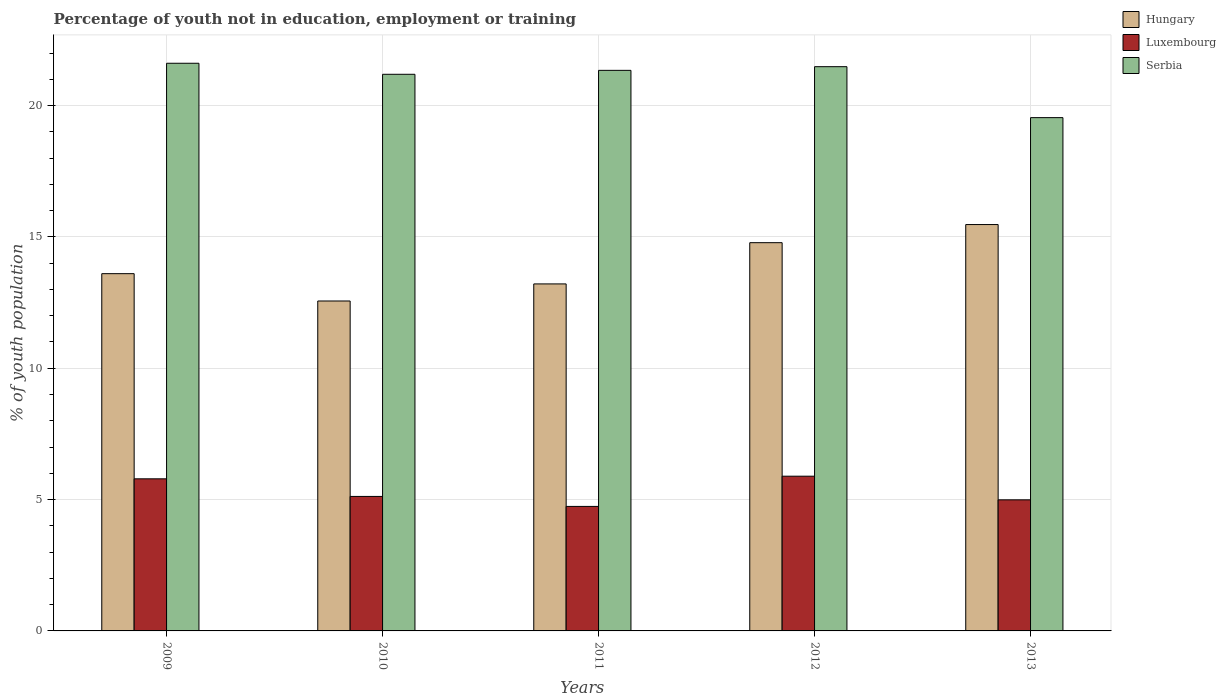How many groups of bars are there?
Offer a terse response. 5. Are the number of bars per tick equal to the number of legend labels?
Provide a succinct answer. Yes. Are the number of bars on each tick of the X-axis equal?
Offer a very short reply. Yes. How many bars are there on the 2nd tick from the left?
Keep it short and to the point. 3. What is the percentage of unemployed youth population in in Serbia in 2013?
Your answer should be very brief. 19.54. Across all years, what is the maximum percentage of unemployed youth population in in Hungary?
Your response must be concise. 15.47. Across all years, what is the minimum percentage of unemployed youth population in in Hungary?
Offer a terse response. 12.56. In which year was the percentage of unemployed youth population in in Serbia maximum?
Your answer should be very brief. 2009. In which year was the percentage of unemployed youth population in in Hungary minimum?
Offer a terse response. 2010. What is the total percentage of unemployed youth population in in Hungary in the graph?
Your answer should be very brief. 69.62. What is the difference between the percentage of unemployed youth population in in Hungary in 2011 and that in 2013?
Keep it short and to the point. -2.26. What is the difference between the percentage of unemployed youth population in in Serbia in 2009 and the percentage of unemployed youth population in in Luxembourg in 2013?
Offer a very short reply. 16.62. What is the average percentage of unemployed youth population in in Hungary per year?
Your answer should be very brief. 13.92. In the year 2010, what is the difference between the percentage of unemployed youth population in in Luxembourg and percentage of unemployed youth population in in Hungary?
Make the answer very short. -7.44. What is the ratio of the percentage of unemployed youth population in in Serbia in 2011 to that in 2012?
Your answer should be very brief. 0.99. Is the difference between the percentage of unemployed youth population in in Luxembourg in 2009 and 2012 greater than the difference between the percentage of unemployed youth population in in Hungary in 2009 and 2012?
Ensure brevity in your answer.  Yes. What is the difference between the highest and the second highest percentage of unemployed youth population in in Hungary?
Offer a very short reply. 0.69. What is the difference between the highest and the lowest percentage of unemployed youth population in in Luxembourg?
Your answer should be very brief. 1.15. In how many years, is the percentage of unemployed youth population in in Serbia greater than the average percentage of unemployed youth population in in Serbia taken over all years?
Offer a terse response. 4. What does the 1st bar from the left in 2010 represents?
Provide a short and direct response. Hungary. What does the 3rd bar from the right in 2013 represents?
Offer a very short reply. Hungary. How many bars are there?
Your answer should be compact. 15. What is the difference between two consecutive major ticks on the Y-axis?
Provide a short and direct response. 5. Are the values on the major ticks of Y-axis written in scientific E-notation?
Your answer should be very brief. No. How many legend labels are there?
Your response must be concise. 3. How are the legend labels stacked?
Keep it short and to the point. Vertical. What is the title of the graph?
Provide a short and direct response. Percentage of youth not in education, employment or training. What is the label or title of the Y-axis?
Make the answer very short. % of youth population. What is the % of youth population of Hungary in 2009?
Your response must be concise. 13.6. What is the % of youth population in Luxembourg in 2009?
Give a very brief answer. 5.79. What is the % of youth population in Serbia in 2009?
Give a very brief answer. 21.61. What is the % of youth population of Hungary in 2010?
Give a very brief answer. 12.56. What is the % of youth population of Luxembourg in 2010?
Give a very brief answer. 5.12. What is the % of youth population of Serbia in 2010?
Your response must be concise. 21.19. What is the % of youth population in Hungary in 2011?
Give a very brief answer. 13.21. What is the % of youth population of Luxembourg in 2011?
Provide a short and direct response. 4.74. What is the % of youth population of Serbia in 2011?
Your response must be concise. 21.34. What is the % of youth population in Hungary in 2012?
Offer a very short reply. 14.78. What is the % of youth population in Luxembourg in 2012?
Your answer should be very brief. 5.89. What is the % of youth population in Serbia in 2012?
Your response must be concise. 21.48. What is the % of youth population in Hungary in 2013?
Keep it short and to the point. 15.47. What is the % of youth population of Luxembourg in 2013?
Provide a short and direct response. 4.99. What is the % of youth population in Serbia in 2013?
Make the answer very short. 19.54. Across all years, what is the maximum % of youth population in Hungary?
Keep it short and to the point. 15.47. Across all years, what is the maximum % of youth population of Luxembourg?
Your answer should be very brief. 5.89. Across all years, what is the maximum % of youth population of Serbia?
Your answer should be very brief. 21.61. Across all years, what is the minimum % of youth population in Hungary?
Offer a terse response. 12.56. Across all years, what is the minimum % of youth population in Luxembourg?
Provide a short and direct response. 4.74. Across all years, what is the minimum % of youth population of Serbia?
Your answer should be very brief. 19.54. What is the total % of youth population in Hungary in the graph?
Provide a short and direct response. 69.62. What is the total % of youth population of Luxembourg in the graph?
Offer a very short reply. 26.53. What is the total % of youth population in Serbia in the graph?
Provide a short and direct response. 105.16. What is the difference between the % of youth population in Luxembourg in 2009 and that in 2010?
Keep it short and to the point. 0.67. What is the difference between the % of youth population in Serbia in 2009 and that in 2010?
Your answer should be compact. 0.42. What is the difference between the % of youth population in Hungary in 2009 and that in 2011?
Offer a terse response. 0.39. What is the difference between the % of youth population of Serbia in 2009 and that in 2011?
Ensure brevity in your answer.  0.27. What is the difference between the % of youth population of Hungary in 2009 and that in 2012?
Your answer should be compact. -1.18. What is the difference between the % of youth population in Luxembourg in 2009 and that in 2012?
Provide a succinct answer. -0.1. What is the difference between the % of youth population of Serbia in 2009 and that in 2012?
Keep it short and to the point. 0.13. What is the difference between the % of youth population in Hungary in 2009 and that in 2013?
Provide a short and direct response. -1.87. What is the difference between the % of youth population of Serbia in 2009 and that in 2013?
Give a very brief answer. 2.07. What is the difference between the % of youth population of Hungary in 2010 and that in 2011?
Your answer should be very brief. -0.65. What is the difference between the % of youth population of Luxembourg in 2010 and that in 2011?
Your response must be concise. 0.38. What is the difference between the % of youth population of Serbia in 2010 and that in 2011?
Offer a very short reply. -0.15. What is the difference between the % of youth population in Hungary in 2010 and that in 2012?
Provide a succinct answer. -2.22. What is the difference between the % of youth population of Luxembourg in 2010 and that in 2012?
Ensure brevity in your answer.  -0.77. What is the difference between the % of youth population of Serbia in 2010 and that in 2012?
Keep it short and to the point. -0.29. What is the difference between the % of youth population in Hungary in 2010 and that in 2013?
Give a very brief answer. -2.91. What is the difference between the % of youth population of Luxembourg in 2010 and that in 2013?
Offer a very short reply. 0.13. What is the difference between the % of youth population of Serbia in 2010 and that in 2013?
Give a very brief answer. 1.65. What is the difference between the % of youth population in Hungary in 2011 and that in 2012?
Your answer should be very brief. -1.57. What is the difference between the % of youth population in Luxembourg in 2011 and that in 2012?
Make the answer very short. -1.15. What is the difference between the % of youth population of Serbia in 2011 and that in 2012?
Keep it short and to the point. -0.14. What is the difference between the % of youth population in Hungary in 2011 and that in 2013?
Offer a terse response. -2.26. What is the difference between the % of youth population in Hungary in 2012 and that in 2013?
Give a very brief answer. -0.69. What is the difference between the % of youth population of Luxembourg in 2012 and that in 2013?
Make the answer very short. 0.9. What is the difference between the % of youth population in Serbia in 2012 and that in 2013?
Make the answer very short. 1.94. What is the difference between the % of youth population in Hungary in 2009 and the % of youth population in Luxembourg in 2010?
Offer a terse response. 8.48. What is the difference between the % of youth population of Hungary in 2009 and the % of youth population of Serbia in 2010?
Give a very brief answer. -7.59. What is the difference between the % of youth population in Luxembourg in 2009 and the % of youth population in Serbia in 2010?
Your answer should be very brief. -15.4. What is the difference between the % of youth population of Hungary in 2009 and the % of youth population of Luxembourg in 2011?
Your answer should be compact. 8.86. What is the difference between the % of youth population in Hungary in 2009 and the % of youth population in Serbia in 2011?
Offer a very short reply. -7.74. What is the difference between the % of youth population in Luxembourg in 2009 and the % of youth population in Serbia in 2011?
Provide a succinct answer. -15.55. What is the difference between the % of youth population in Hungary in 2009 and the % of youth population in Luxembourg in 2012?
Keep it short and to the point. 7.71. What is the difference between the % of youth population of Hungary in 2009 and the % of youth population of Serbia in 2012?
Your response must be concise. -7.88. What is the difference between the % of youth population of Luxembourg in 2009 and the % of youth population of Serbia in 2012?
Provide a succinct answer. -15.69. What is the difference between the % of youth population of Hungary in 2009 and the % of youth population of Luxembourg in 2013?
Provide a short and direct response. 8.61. What is the difference between the % of youth population of Hungary in 2009 and the % of youth population of Serbia in 2013?
Your answer should be compact. -5.94. What is the difference between the % of youth population of Luxembourg in 2009 and the % of youth population of Serbia in 2013?
Offer a very short reply. -13.75. What is the difference between the % of youth population in Hungary in 2010 and the % of youth population in Luxembourg in 2011?
Offer a terse response. 7.82. What is the difference between the % of youth population of Hungary in 2010 and the % of youth population of Serbia in 2011?
Offer a terse response. -8.78. What is the difference between the % of youth population of Luxembourg in 2010 and the % of youth population of Serbia in 2011?
Ensure brevity in your answer.  -16.22. What is the difference between the % of youth population of Hungary in 2010 and the % of youth population of Luxembourg in 2012?
Your answer should be compact. 6.67. What is the difference between the % of youth population of Hungary in 2010 and the % of youth population of Serbia in 2012?
Your answer should be very brief. -8.92. What is the difference between the % of youth population in Luxembourg in 2010 and the % of youth population in Serbia in 2012?
Your answer should be very brief. -16.36. What is the difference between the % of youth population in Hungary in 2010 and the % of youth population in Luxembourg in 2013?
Your answer should be very brief. 7.57. What is the difference between the % of youth population in Hungary in 2010 and the % of youth population in Serbia in 2013?
Your response must be concise. -6.98. What is the difference between the % of youth population in Luxembourg in 2010 and the % of youth population in Serbia in 2013?
Ensure brevity in your answer.  -14.42. What is the difference between the % of youth population in Hungary in 2011 and the % of youth population in Luxembourg in 2012?
Provide a succinct answer. 7.32. What is the difference between the % of youth population in Hungary in 2011 and the % of youth population in Serbia in 2012?
Provide a short and direct response. -8.27. What is the difference between the % of youth population of Luxembourg in 2011 and the % of youth population of Serbia in 2012?
Make the answer very short. -16.74. What is the difference between the % of youth population of Hungary in 2011 and the % of youth population of Luxembourg in 2013?
Your answer should be very brief. 8.22. What is the difference between the % of youth population of Hungary in 2011 and the % of youth population of Serbia in 2013?
Make the answer very short. -6.33. What is the difference between the % of youth population in Luxembourg in 2011 and the % of youth population in Serbia in 2013?
Keep it short and to the point. -14.8. What is the difference between the % of youth population of Hungary in 2012 and the % of youth population of Luxembourg in 2013?
Your answer should be compact. 9.79. What is the difference between the % of youth population of Hungary in 2012 and the % of youth population of Serbia in 2013?
Ensure brevity in your answer.  -4.76. What is the difference between the % of youth population of Luxembourg in 2012 and the % of youth population of Serbia in 2013?
Offer a terse response. -13.65. What is the average % of youth population of Hungary per year?
Offer a very short reply. 13.92. What is the average % of youth population in Luxembourg per year?
Your answer should be compact. 5.31. What is the average % of youth population in Serbia per year?
Offer a terse response. 21.03. In the year 2009, what is the difference between the % of youth population of Hungary and % of youth population of Luxembourg?
Make the answer very short. 7.81. In the year 2009, what is the difference between the % of youth population of Hungary and % of youth population of Serbia?
Keep it short and to the point. -8.01. In the year 2009, what is the difference between the % of youth population in Luxembourg and % of youth population in Serbia?
Provide a short and direct response. -15.82. In the year 2010, what is the difference between the % of youth population in Hungary and % of youth population in Luxembourg?
Make the answer very short. 7.44. In the year 2010, what is the difference between the % of youth population of Hungary and % of youth population of Serbia?
Ensure brevity in your answer.  -8.63. In the year 2010, what is the difference between the % of youth population of Luxembourg and % of youth population of Serbia?
Provide a succinct answer. -16.07. In the year 2011, what is the difference between the % of youth population in Hungary and % of youth population in Luxembourg?
Provide a short and direct response. 8.47. In the year 2011, what is the difference between the % of youth population in Hungary and % of youth population in Serbia?
Offer a terse response. -8.13. In the year 2011, what is the difference between the % of youth population in Luxembourg and % of youth population in Serbia?
Your answer should be compact. -16.6. In the year 2012, what is the difference between the % of youth population of Hungary and % of youth population of Luxembourg?
Your answer should be compact. 8.89. In the year 2012, what is the difference between the % of youth population in Luxembourg and % of youth population in Serbia?
Provide a short and direct response. -15.59. In the year 2013, what is the difference between the % of youth population of Hungary and % of youth population of Luxembourg?
Make the answer very short. 10.48. In the year 2013, what is the difference between the % of youth population of Hungary and % of youth population of Serbia?
Keep it short and to the point. -4.07. In the year 2013, what is the difference between the % of youth population in Luxembourg and % of youth population in Serbia?
Ensure brevity in your answer.  -14.55. What is the ratio of the % of youth population in Hungary in 2009 to that in 2010?
Keep it short and to the point. 1.08. What is the ratio of the % of youth population of Luxembourg in 2009 to that in 2010?
Make the answer very short. 1.13. What is the ratio of the % of youth population of Serbia in 2009 to that in 2010?
Your answer should be very brief. 1.02. What is the ratio of the % of youth population of Hungary in 2009 to that in 2011?
Keep it short and to the point. 1.03. What is the ratio of the % of youth population in Luxembourg in 2009 to that in 2011?
Provide a short and direct response. 1.22. What is the ratio of the % of youth population of Serbia in 2009 to that in 2011?
Provide a short and direct response. 1.01. What is the ratio of the % of youth population of Hungary in 2009 to that in 2012?
Ensure brevity in your answer.  0.92. What is the ratio of the % of youth population of Hungary in 2009 to that in 2013?
Provide a short and direct response. 0.88. What is the ratio of the % of youth population in Luxembourg in 2009 to that in 2013?
Your response must be concise. 1.16. What is the ratio of the % of youth population in Serbia in 2009 to that in 2013?
Your answer should be very brief. 1.11. What is the ratio of the % of youth population of Hungary in 2010 to that in 2011?
Your answer should be compact. 0.95. What is the ratio of the % of youth population of Luxembourg in 2010 to that in 2011?
Make the answer very short. 1.08. What is the ratio of the % of youth population of Hungary in 2010 to that in 2012?
Your response must be concise. 0.85. What is the ratio of the % of youth population in Luxembourg in 2010 to that in 2012?
Keep it short and to the point. 0.87. What is the ratio of the % of youth population of Serbia in 2010 to that in 2012?
Your answer should be compact. 0.99. What is the ratio of the % of youth population of Hungary in 2010 to that in 2013?
Provide a succinct answer. 0.81. What is the ratio of the % of youth population in Luxembourg in 2010 to that in 2013?
Keep it short and to the point. 1.03. What is the ratio of the % of youth population of Serbia in 2010 to that in 2013?
Make the answer very short. 1.08. What is the ratio of the % of youth population of Hungary in 2011 to that in 2012?
Make the answer very short. 0.89. What is the ratio of the % of youth population in Luxembourg in 2011 to that in 2012?
Your answer should be compact. 0.8. What is the ratio of the % of youth population of Serbia in 2011 to that in 2012?
Give a very brief answer. 0.99. What is the ratio of the % of youth population of Hungary in 2011 to that in 2013?
Provide a succinct answer. 0.85. What is the ratio of the % of youth population in Luxembourg in 2011 to that in 2013?
Offer a terse response. 0.95. What is the ratio of the % of youth population in Serbia in 2011 to that in 2013?
Keep it short and to the point. 1.09. What is the ratio of the % of youth population of Hungary in 2012 to that in 2013?
Give a very brief answer. 0.96. What is the ratio of the % of youth population in Luxembourg in 2012 to that in 2013?
Your answer should be compact. 1.18. What is the ratio of the % of youth population in Serbia in 2012 to that in 2013?
Make the answer very short. 1.1. What is the difference between the highest and the second highest % of youth population of Hungary?
Provide a short and direct response. 0.69. What is the difference between the highest and the second highest % of youth population of Serbia?
Make the answer very short. 0.13. What is the difference between the highest and the lowest % of youth population of Hungary?
Provide a succinct answer. 2.91. What is the difference between the highest and the lowest % of youth population in Luxembourg?
Keep it short and to the point. 1.15. What is the difference between the highest and the lowest % of youth population in Serbia?
Your answer should be compact. 2.07. 